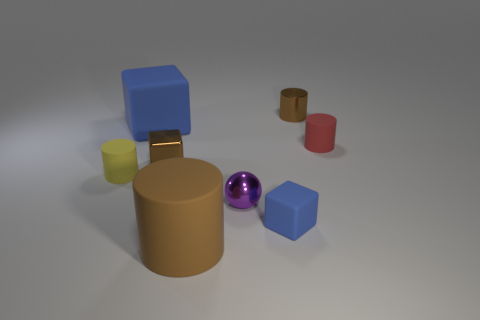Subtract all red cylinders. How many cylinders are left? 3 Subtract all brown spheres. How many blue blocks are left? 2 Subtract 1 blocks. How many blocks are left? 2 Subtract all blue cylinders. Subtract all brown blocks. How many cylinders are left? 4 Subtract all balls. How many objects are left? 7 Add 2 small red matte cylinders. How many objects exist? 10 Add 3 small yellow matte things. How many small yellow matte things exist? 4 Subtract 0 brown balls. How many objects are left? 8 Subtract all brown rubber cylinders. Subtract all small brown metallic things. How many objects are left? 5 Add 5 tiny matte cylinders. How many tiny matte cylinders are left? 7 